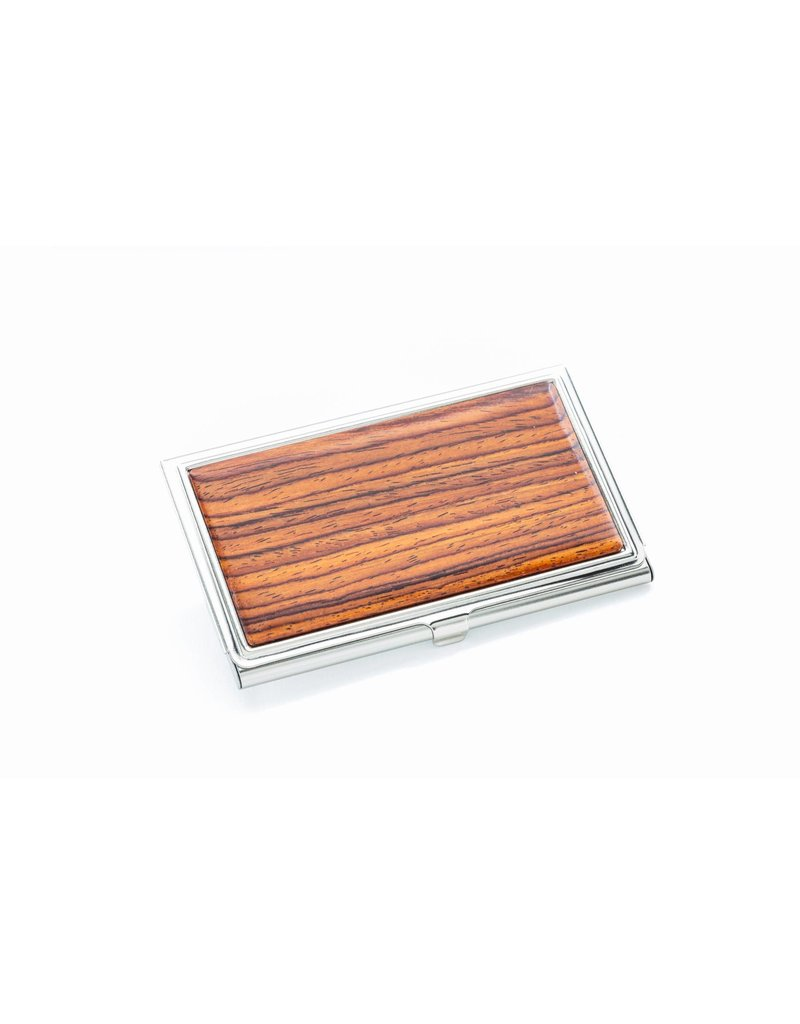Can you tell what the silver-looking material of the case might be? The outer material of the case appears to be a lustrous, silver-colored metal, which suggests it could be made from stainless steel, silver, or a silver-plated alloy. Stainless steel is known for its durability and resistance to corrosion, making it an excellent choice for everyday items that are handled frequently. On the other hand, silver or silver-plated materials would provide an elegant touch with a classic aesthetic but might require more upkeep to prevent tarnish. To determine the exact material, one would need more information or a closer examination, possibly involving tests to verify the composition. 